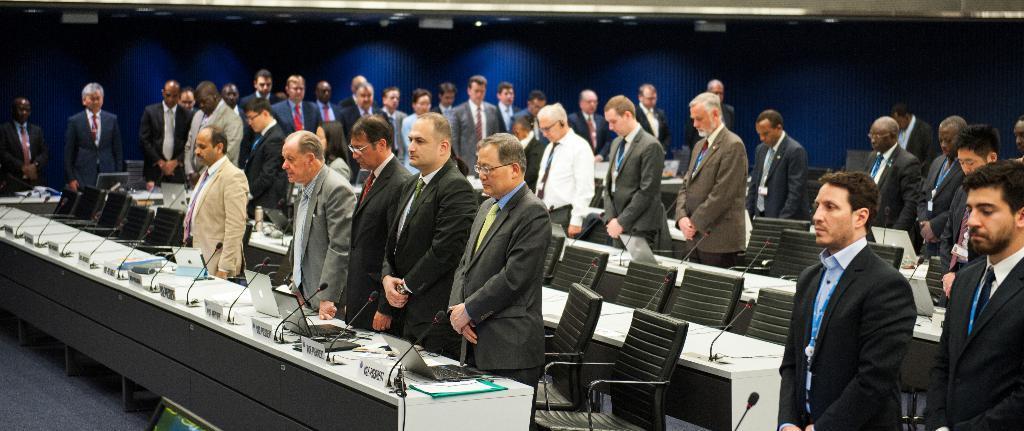Please provide a concise description of this image. In this image we can see the people standing near the table. On the table there are laptops, microphones and boards with text. There are chairs and dark background. 